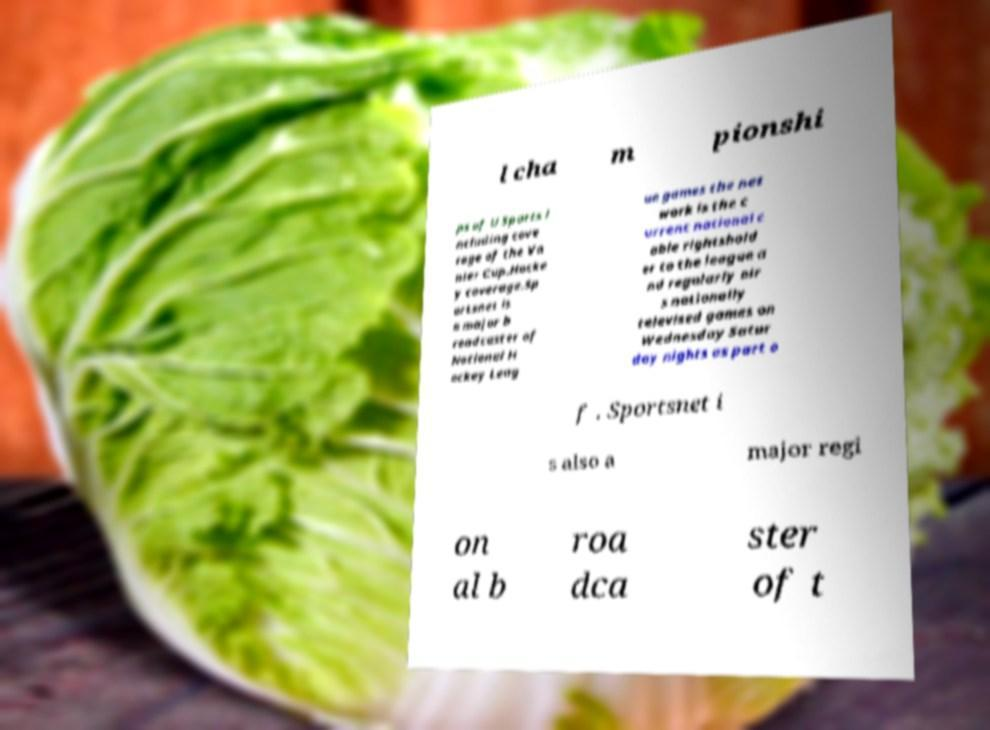What messages or text are displayed in this image? I need them in a readable, typed format. l cha m pionshi ps of U Sports i ncluding cove rage of the Va nier Cup.Hocke y coverage.Sp ortsnet is a major b roadcaster of National H ockey Leag ue games the net work is the c urrent national c able rightshold er to the league a nd regularly air s nationally televised games on Wednesday Satur day nights as part o f . Sportsnet i s also a major regi on al b roa dca ster of t 